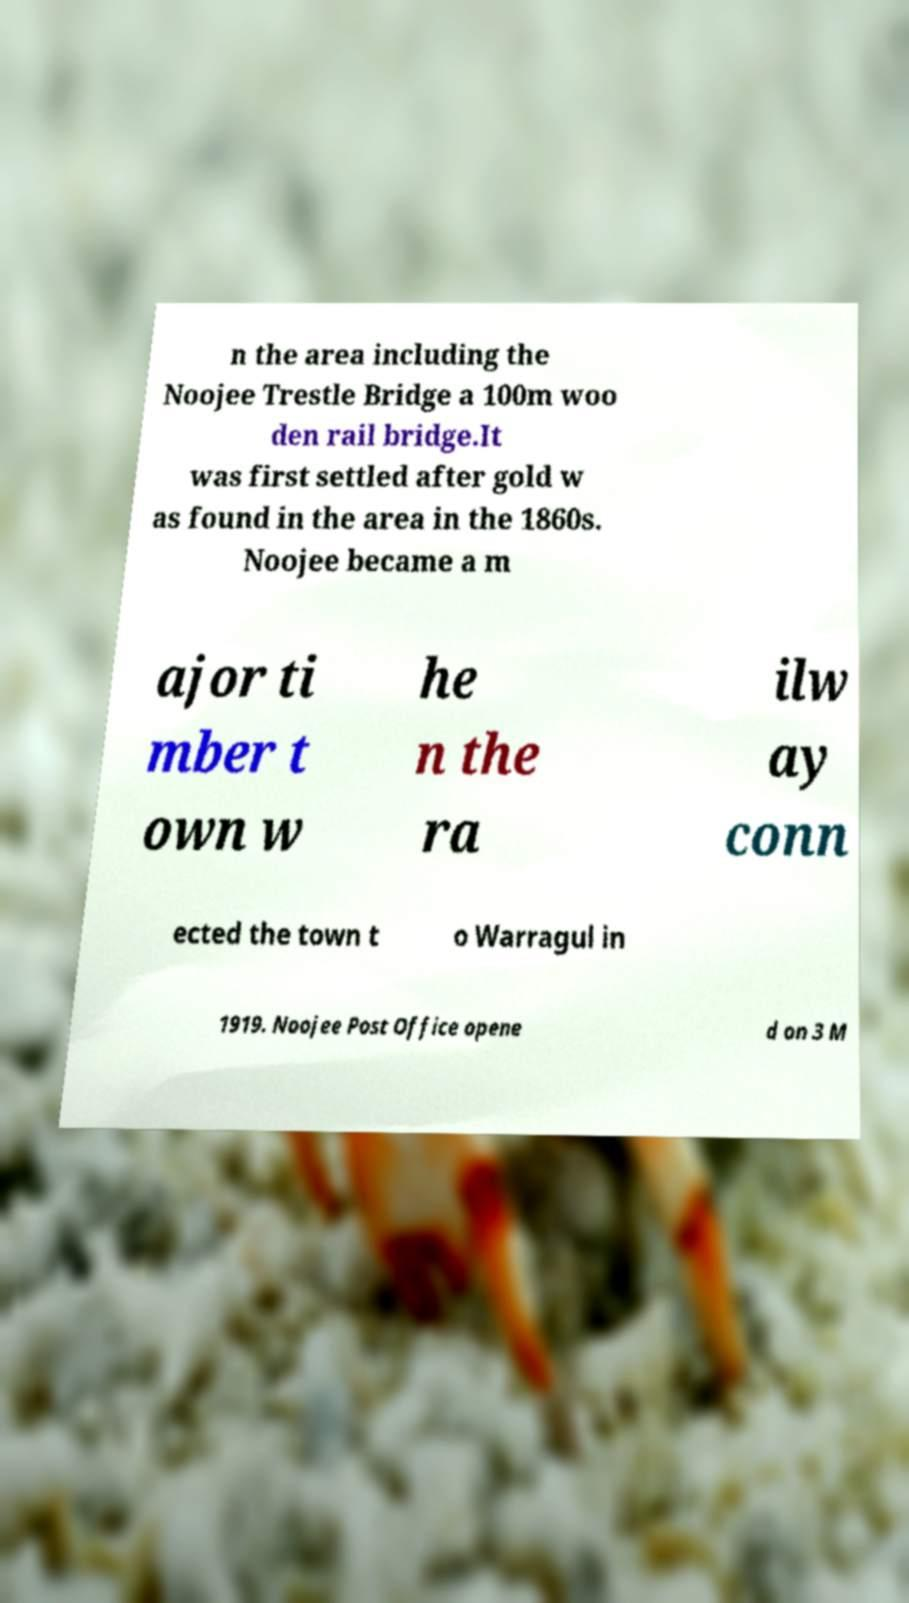Can you read and provide the text displayed in the image?This photo seems to have some interesting text. Can you extract and type it out for me? n the area including the Noojee Trestle Bridge a 100m woo den rail bridge.It was first settled after gold w as found in the area in the 1860s. Noojee became a m ajor ti mber t own w he n the ra ilw ay conn ected the town t o Warragul in 1919. Noojee Post Office opene d on 3 M 